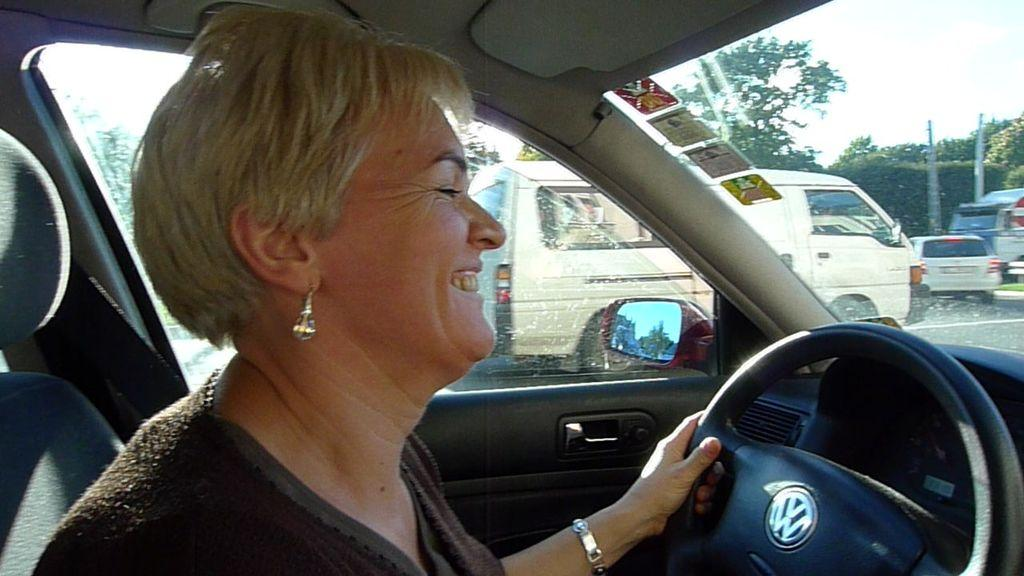What is the woman in the image doing? The woman is driving a car in the image. What is the woman's facial expression in the image? The woman is smiling in the image. What can be seen on the road in the image? There are parked cars on the road in the image. What type of vegetation is visible in the image? There are trees visible in the image. What type of health advice can be seen printed on the car's dashboard in the image? There is no health advice or print visible on the car's dashboard in the image. 